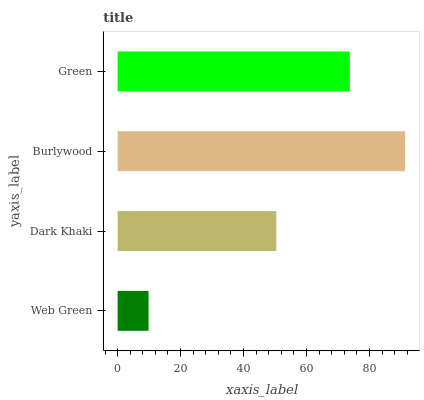Is Web Green the minimum?
Answer yes or no. Yes. Is Burlywood the maximum?
Answer yes or no. Yes. Is Dark Khaki the minimum?
Answer yes or no. No. Is Dark Khaki the maximum?
Answer yes or no. No. Is Dark Khaki greater than Web Green?
Answer yes or no. Yes. Is Web Green less than Dark Khaki?
Answer yes or no. Yes. Is Web Green greater than Dark Khaki?
Answer yes or no. No. Is Dark Khaki less than Web Green?
Answer yes or no. No. Is Green the high median?
Answer yes or no. Yes. Is Dark Khaki the low median?
Answer yes or no. Yes. Is Dark Khaki the high median?
Answer yes or no. No. Is Web Green the low median?
Answer yes or no. No. 